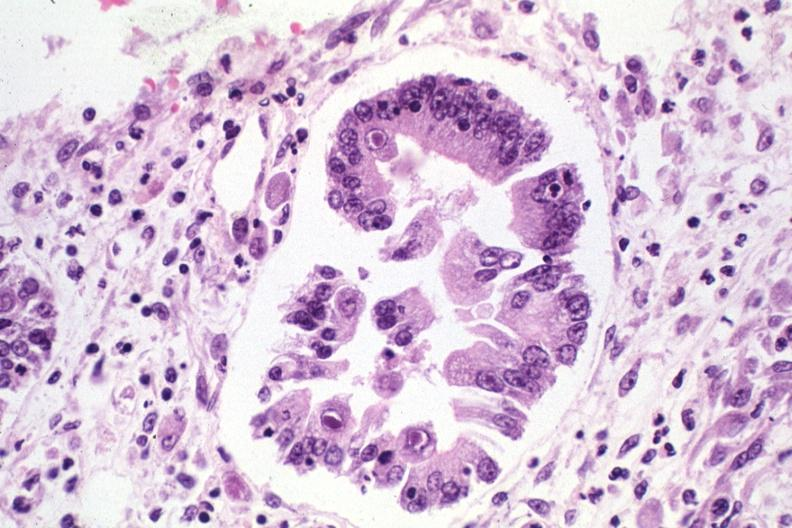does atrophy show inclusion bodies?
Answer the question using a single word or phrase. No 